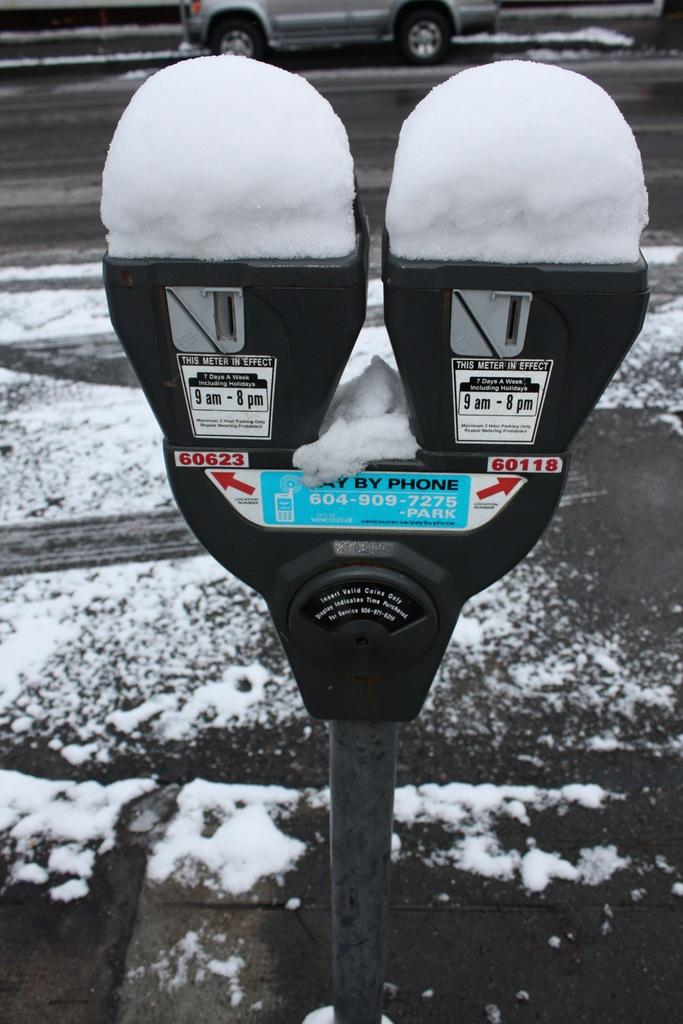<image>
Offer a succinct explanation of the picture presented. A parking meter that is in effect all seven days of the week. 